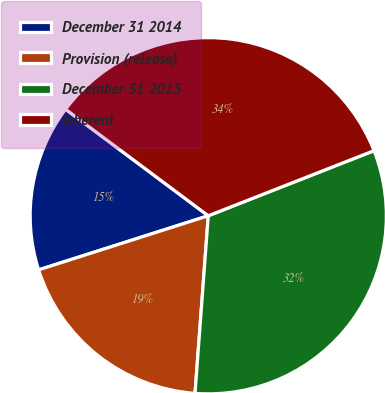<chart> <loc_0><loc_0><loc_500><loc_500><pie_chart><fcel>December 31 2014<fcel>Provision (release)<fcel>December 31 2015<fcel>Inherent<nl><fcel>15.12%<fcel>18.9%<fcel>32.14%<fcel>33.84%<nl></chart> 